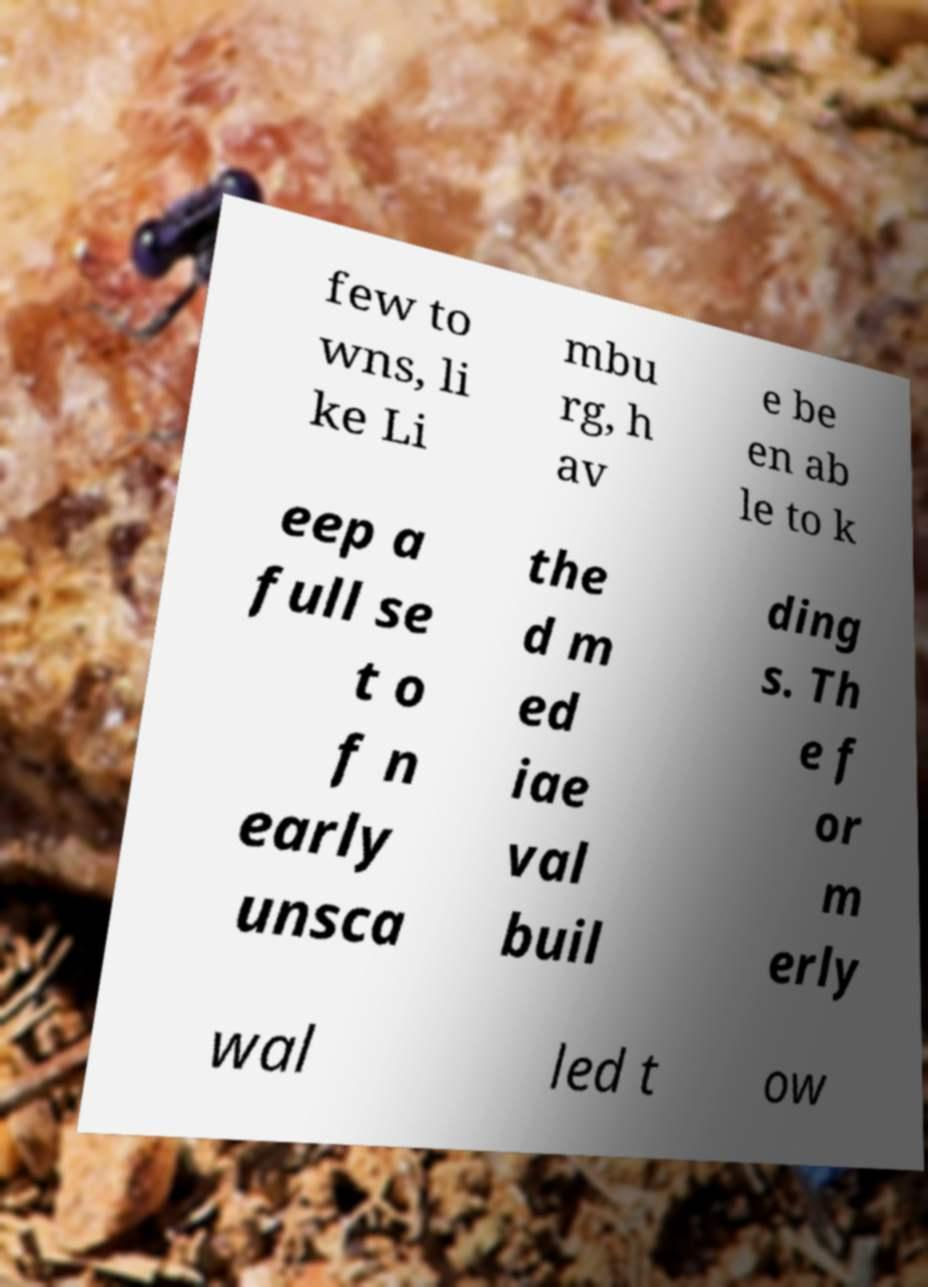Can you accurately transcribe the text from the provided image for me? few to wns, li ke Li mbu rg, h av e be en ab le to k eep a full se t o f n early unsca the d m ed iae val buil ding s. Th e f or m erly wal led t ow 